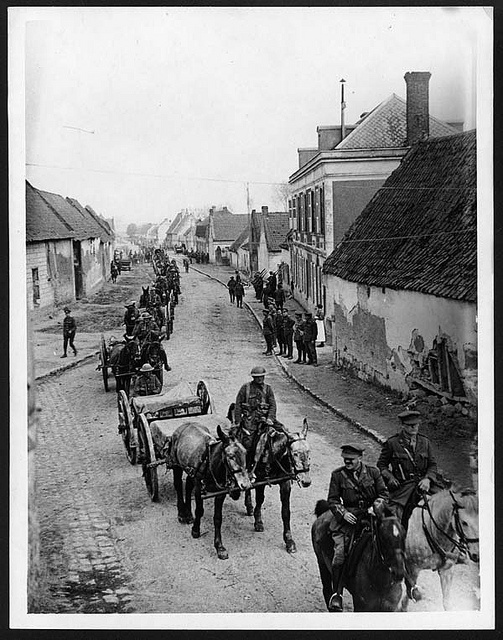Describe the objects in this image and their specific colors. I can see horse in black, gray, darkgray, and lightgray tones, people in black, darkgray, gray, and lightgray tones, horse in black, gray, darkgray, and lightgray tones, horse in black, gray, darkgray, and lightgray tones, and people in black, gray, darkgray, and lightgray tones in this image. 